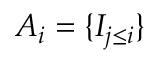Convert formula to latex. <formula><loc_0><loc_0><loc_500><loc_500>A _ { i } = \{ I _ { j \leq i } \}</formula> 